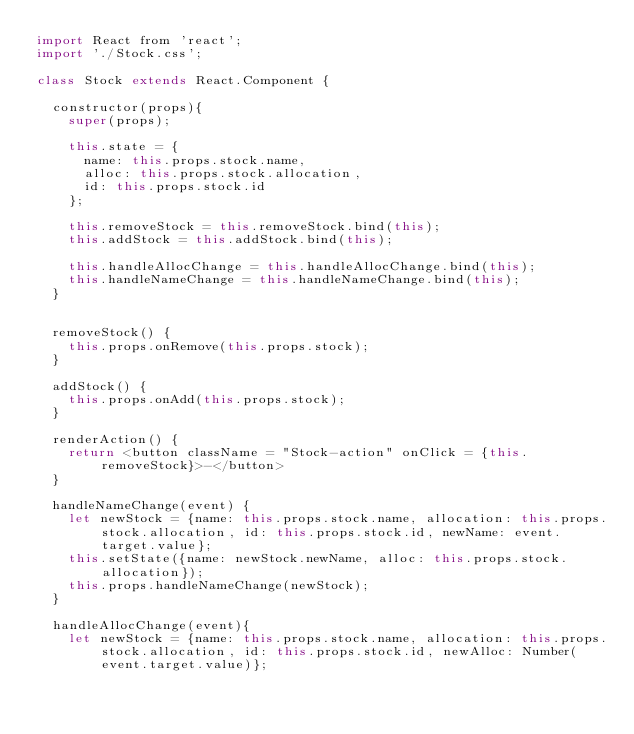Convert code to text. <code><loc_0><loc_0><loc_500><loc_500><_JavaScript_>import React from 'react';
import './Stock.css';

class Stock extends React.Component {

  constructor(props){
    super(props);

    this.state = {
      name: this.props.stock.name,
      alloc: this.props.stock.allocation,
      id: this.props.stock.id
    };

    this.removeStock = this.removeStock.bind(this);
    this.addStock = this.addStock.bind(this);

    this.handleAllocChange = this.handleAllocChange.bind(this);
    this.handleNameChange = this.handleNameChange.bind(this);
  }


  removeStock() {
    this.props.onRemove(this.props.stock);
  }

  addStock() {
    this.props.onAdd(this.props.stock);
  }

  renderAction() {
    return <button className = "Stock-action" onClick = {this.removeStock}>-</button>
  }

  handleNameChange(event) {
    let newStock = {name: this.props.stock.name, allocation: this.props.stock.allocation, id: this.props.stock.id, newName: event.target.value};
    this.setState({name: newStock.newName, alloc: this.props.stock.allocation});
    this.props.handleNameChange(newStock);
  }

  handleAllocChange(event){
    let newStock = {name: this.props.stock.name, allocation: this.props.stock.allocation, id: this.props.stock.id, newAlloc: Number(event.target.value)};</code> 